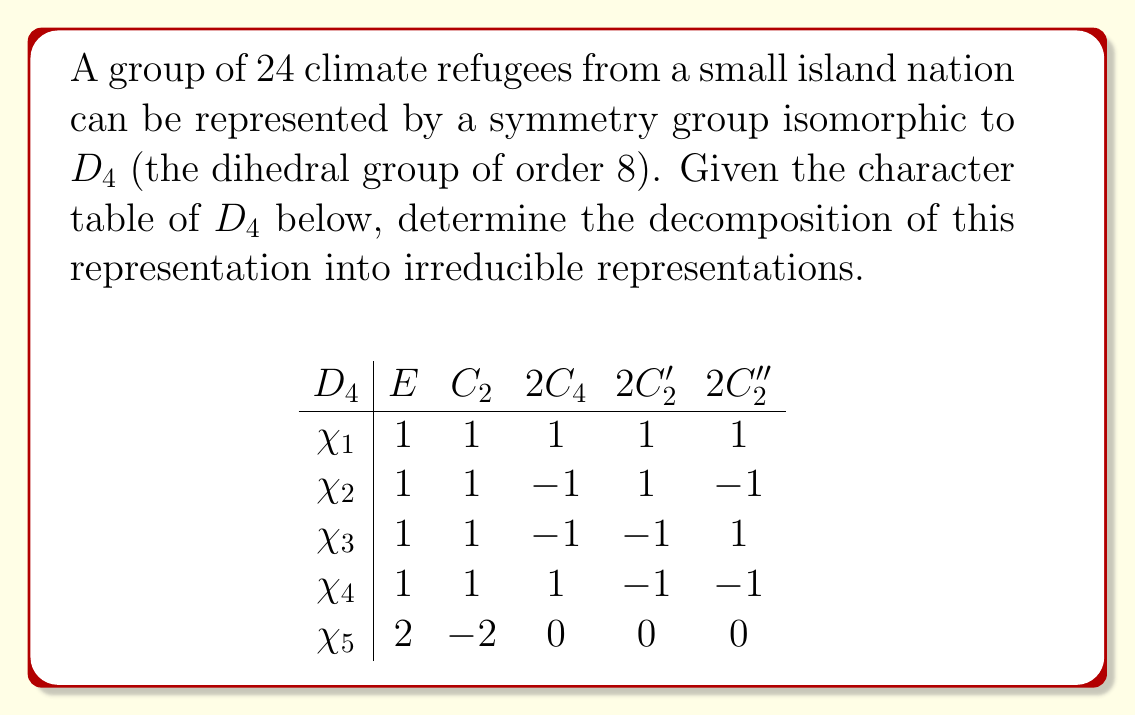Provide a solution to this math problem. To solve this problem, we'll follow these steps:

1) First, we need to determine the character of our representation. Since we have 24 refugees, this is a 24-dimensional representation. Let's call its character $\chi$.

2) For each conjugacy class, $\chi$ will be the number of elements fixed by a representative of that class:

   $\chi(E) = 24$ (identity fixes all elements)
   $\chi(C_2) = 0$ (180° rotation fixes no one)
   $\chi(C_4) = 0$ (90° rotation fixes no one)
   $\chi(C_2') = 4$ (reflection across a diagonal fixes 4 people)
   $\chi(C_2'') = 4$ (reflection across a midline fixes 4 people)

3) Now we need to decompose $\chi$ into irreducible representations. We can do this by calculating the inner product of $\chi$ with each irreducible representation $\chi_i$:

   $a_i = \frac{1}{|G|}\sum_{g \in G} \chi(g)\overline{\chi_i(g)}$

4) Calculating each $a_i$:

   $a_1 = \frac{1}{8}(24 + 0 + 2(0) + 2(4) + 2(4)) = 4$
   $a_2 = \frac{1}{8}(24 + 0 - 2(0) + 2(4) - 2(4)) = 3$
   $a_3 = \frac{1}{8}(24 + 0 - 2(0) - 2(4) + 2(4)) = 3$
   $a_4 = \frac{1}{8}(24 + 0 + 2(0) - 2(4) - 2(4)) = 2$
   $a_5 = \frac{1}{8}(48 + 0 + 0 + 0 + 0) = 6$

5) Therefore, our representation decomposes as:

   $\chi = 4\chi_1 \oplus 3\chi_2 \oplus 3\chi_3 \oplus 2\chi_4 \oplus 6\chi_5$

This decomposition represents how the group of refugees can be organized according to the symmetries of $D_4$.
Answer: $4\chi_1 \oplus 3\chi_2 \oplus 3\chi_3 \oplus 2\chi_4 \oplus 6\chi_5$ 